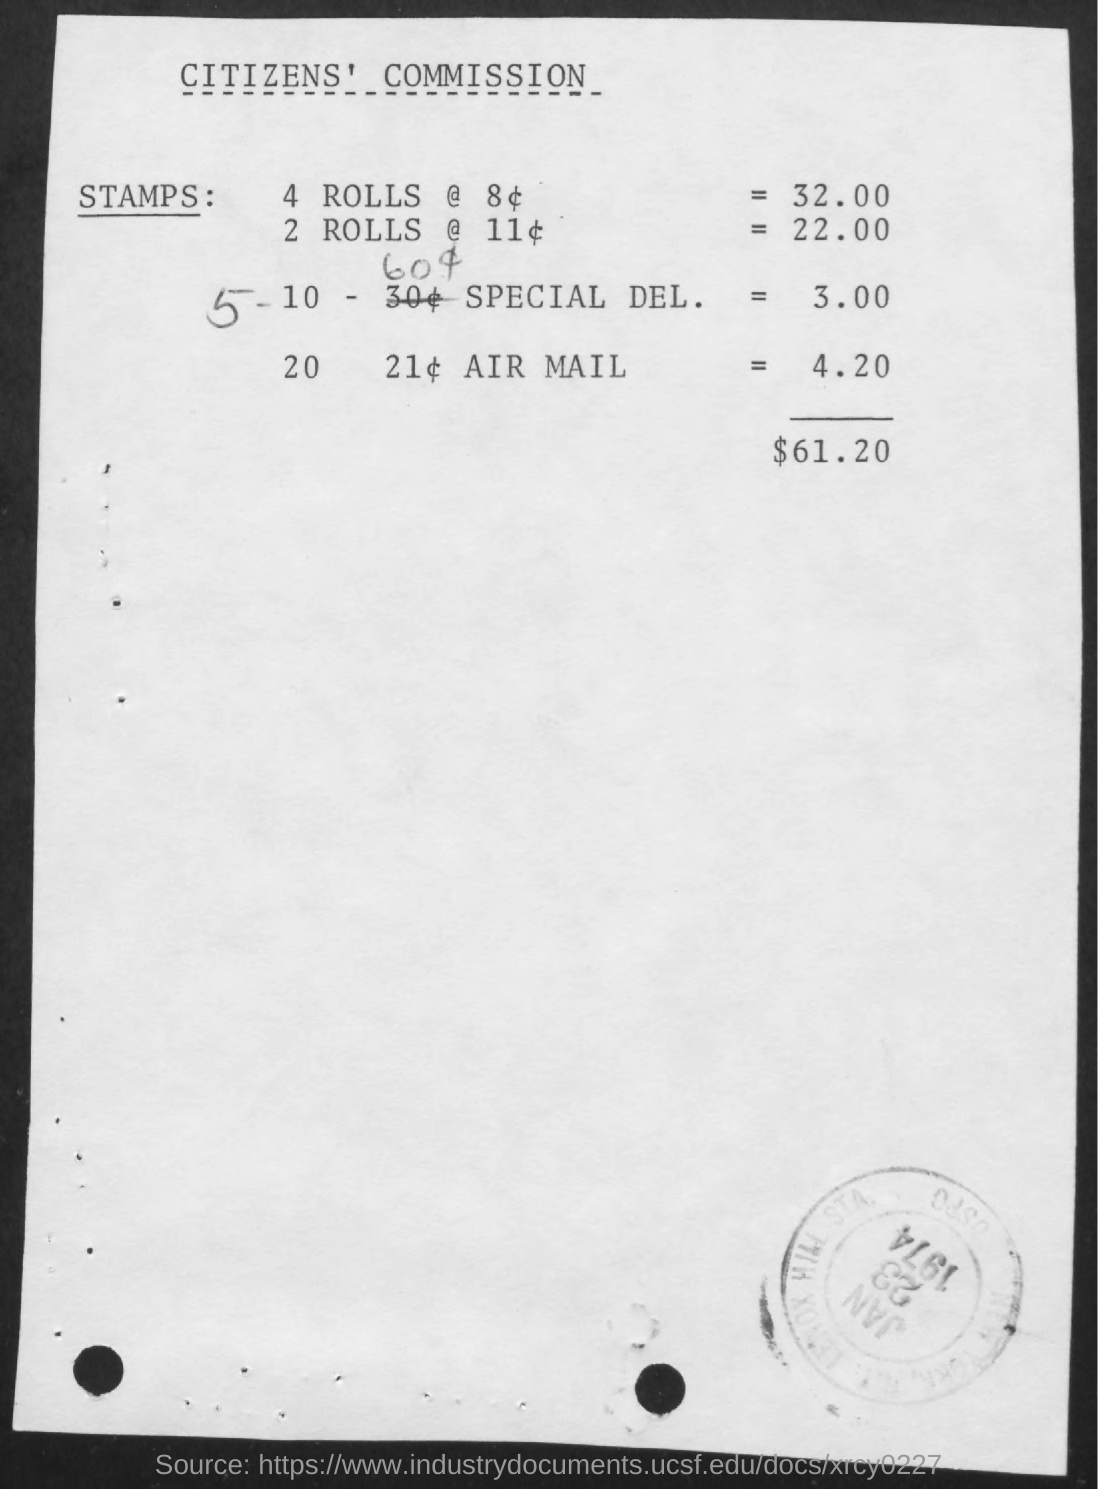What is the Title of the document?
Keep it short and to the point. Citizens' Commission. What is the Total?
Your response must be concise. $61.20. 